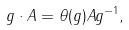Convert formula to latex. <formula><loc_0><loc_0><loc_500><loc_500>g \cdot A = \theta ( g ) A g ^ { - 1 } ,</formula> 